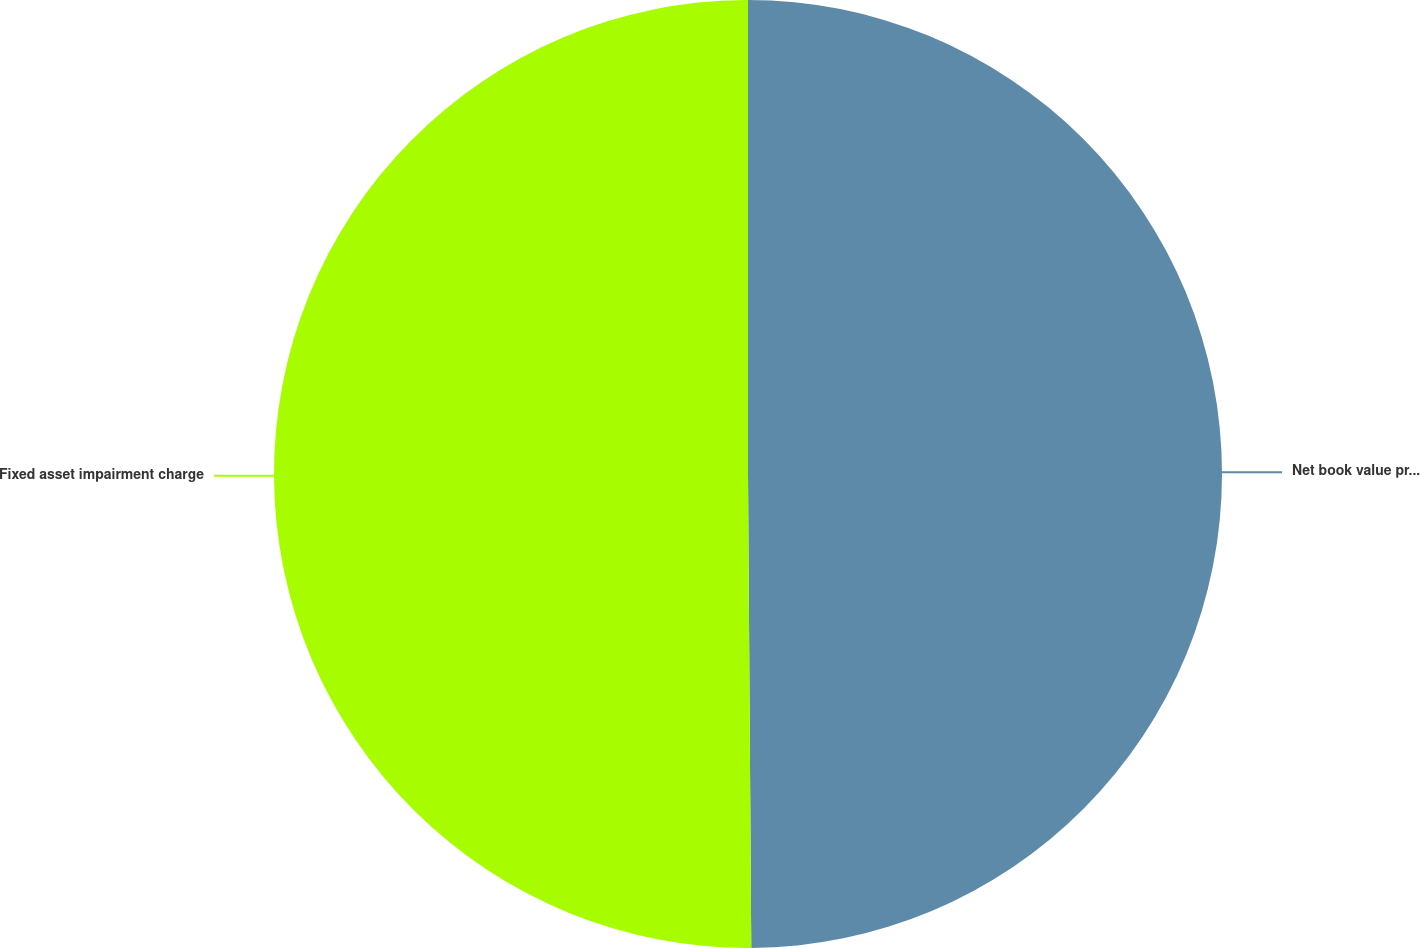<chart> <loc_0><loc_0><loc_500><loc_500><pie_chart><fcel>Net book value prior to<fcel>Fixed asset impairment charge<nl><fcel>49.89%<fcel>50.11%<nl></chart> 